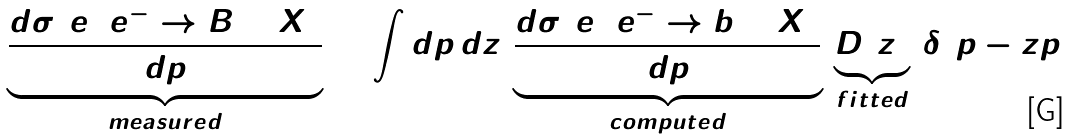Convert formula to latex. <formula><loc_0><loc_0><loc_500><loc_500>\underbrace { \frac { d \sigma ( e ^ { + } e ^ { - } \to B + X ) } { d p } } _ { m e a s u r e d } = \int d \hat { p } \, d z \, \underbrace { \frac { d \sigma ( e ^ { + } e ^ { - } \to b + X ) } { d \hat { p } } } _ { c o m p u t e d } \, \underbrace { D ( z ) } _ { f i t t e d } \, \delta ( p - z \hat { p } )</formula> 